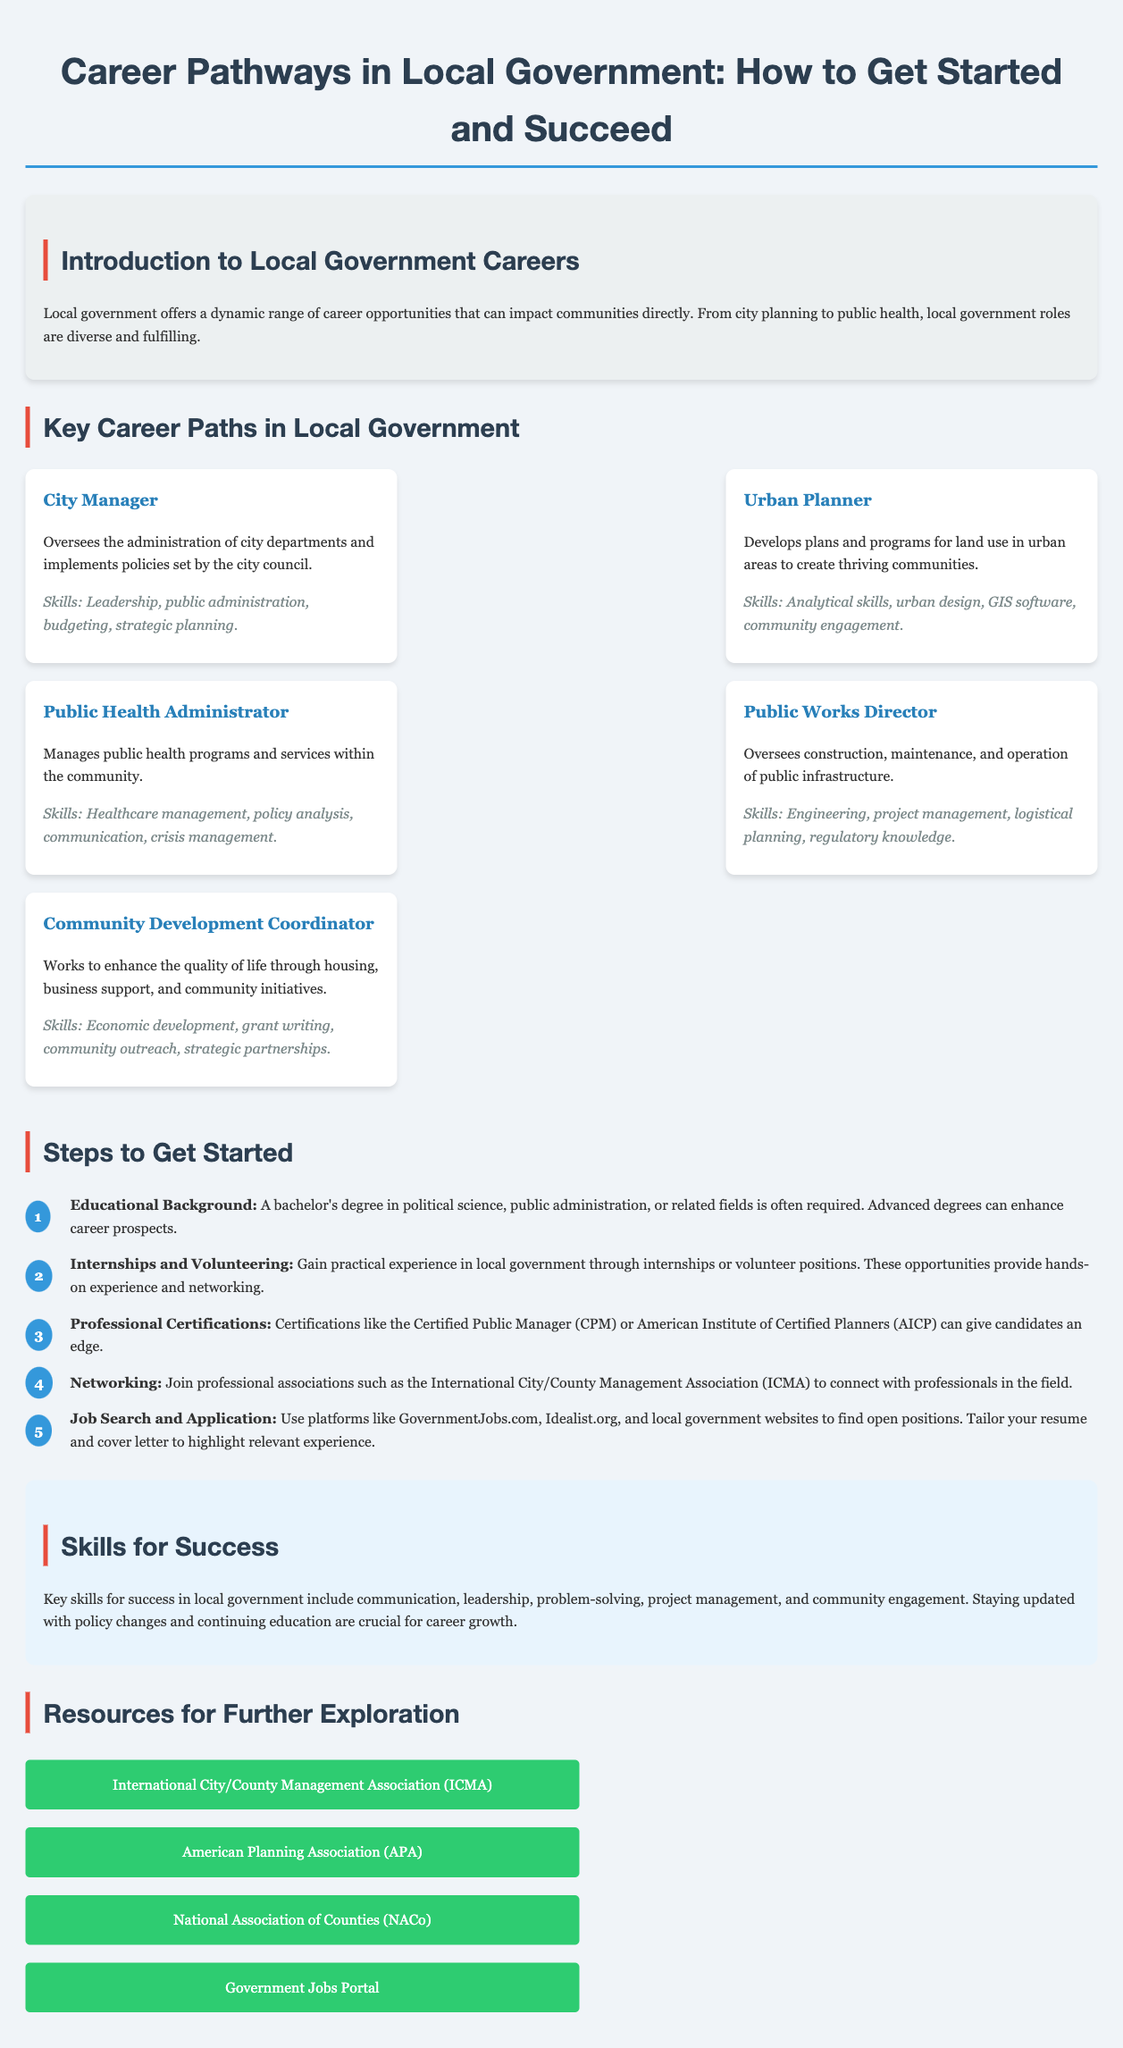What is the title of the infographic? The title is presented at the top of the document, summarizing its main focus on career pathways in local government.
Answer: Career Pathways in Local Government: How to Get Started and Succeed How many key career paths are listed in the document? The document outlines specific career paths in local government, which can be counted in the provided section.
Answer: Five What skill is highlighted for a Public Works Director? The skills for each career are detailed under each job title, providing specific competencies related to the role.
Answer: Engineering What is the first step to get started in a local government career? The steps are numbered in a list format, clearly stating the initial action to begin pursuing a career in this field.
Answer: Educational Background Which organization is mentioned as a resource for networking? The document includes resources for further exploration, listing relevant organizations for professional development.
Answer: International City/County Management Association (ICMA) What is a key skill for success mentioned in the document? The skills necessary for success are emphasized in a specific section of the infographic, highlighting essential abilities.
Answer: Communication What degree is often required for local government roles? The educational requirements are specified in the steps section, outlining the qualifications needed for entry into local government careers.
Answer: Bachelor's degree How many steps are provided for getting started? The document lists a series of steps, which can be counted to understand the process outlined for aspiring local government employees.
Answer: Five 